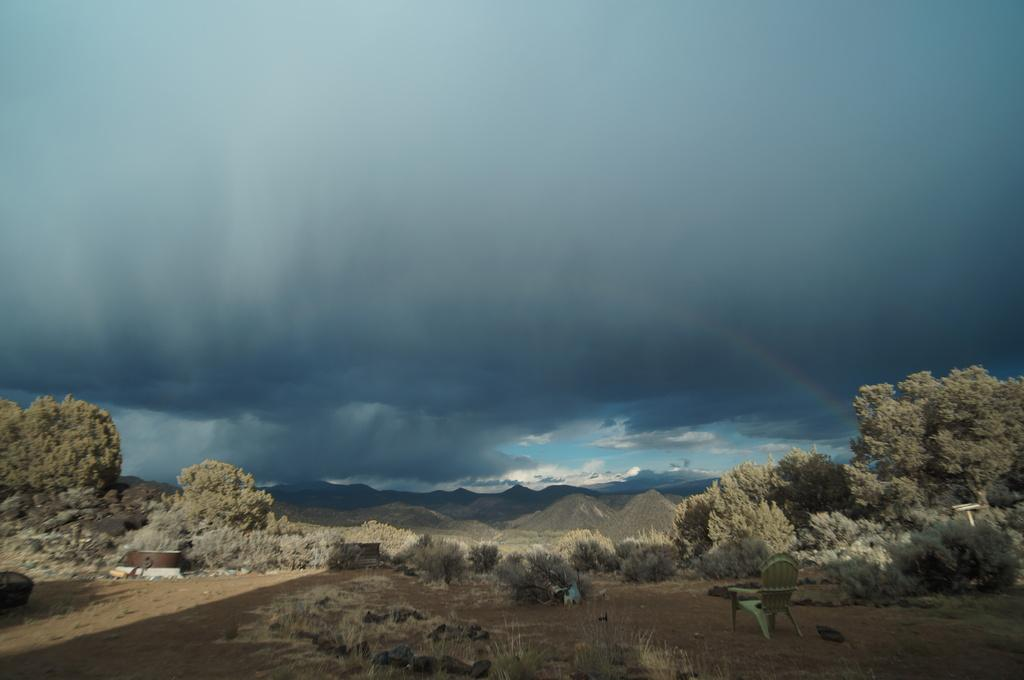What type of natural elements can be seen in the image? There are trees and hills in the image. What is visible in the background of the image? The sky is visible in the image. Can you describe the setting of the image? The image features a natural landscape with trees, hills, and an open sky. What is the object located at the bottom of the image? There is a chair at the bottom of the image. Where is the store located in the image? There is no store present in the image; it features a natural landscape with trees, hills, and an open sky. Can you find the receipt for the purchase of the trees in the image? There is no receipt present in the image, as it is a photograph of a natural landscape. 